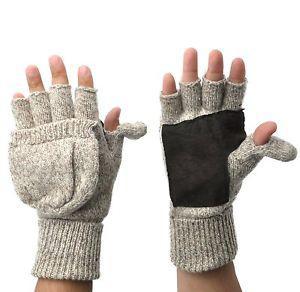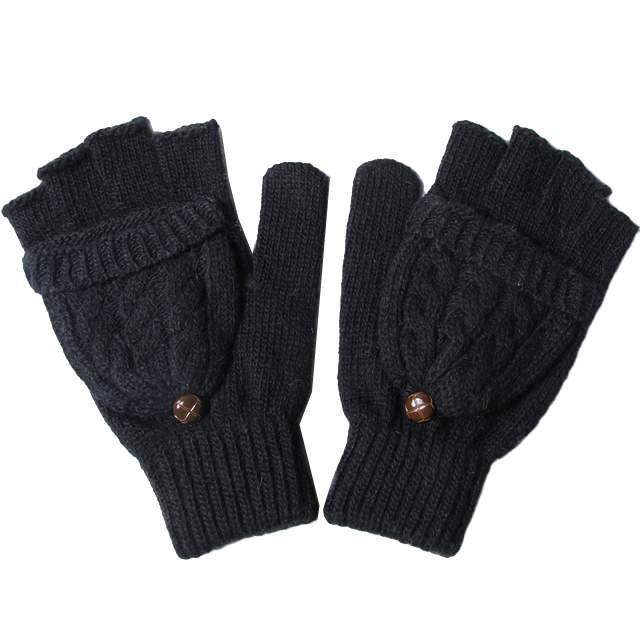The first image is the image on the left, the second image is the image on the right. Considering the images on both sides, is "The right image shows a pair of gloves modeled on human hands, with one glove displaying fingers while the other glove is covered" valid? Answer yes or no. No. The first image is the image on the left, the second image is the image on the right. Examine the images to the left and right. Is the description "In one of the images, human fingers are visible in only one of the two gloves." accurate? Answer yes or no. No. 